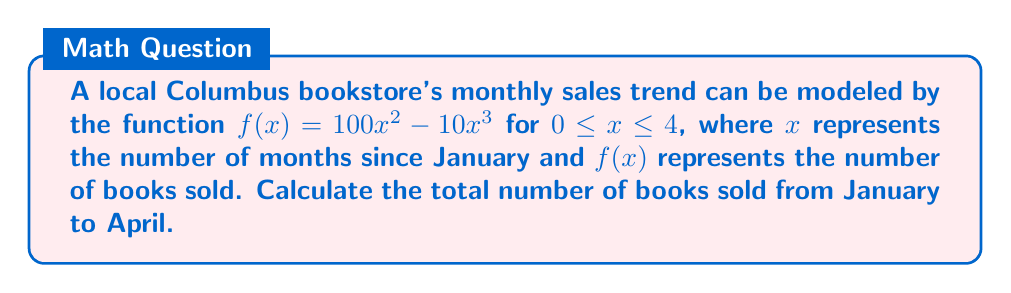Give your solution to this math problem. To find the total number of books sold from January to April, we need to calculate the area under the curve $f(x) = 100x^2 - 10x^3$ from $x = 0$ to $x = 4$. This can be done using a definite integral.

Step 1: Set up the definite integral
$$\int_0^4 (100x^2 - 10x^3) dx$$

Step 2: Integrate the function
$$\left[\frac{100x^3}{3} - \frac{10x^4}{4}\right]_0^4$$

Step 3: Evaluate the integral at the upper and lower bounds
$$\left(\frac{100(4^3)}{3} - \frac{10(4^4)}{4}\right) - \left(\frac{100(0^3)}{3} - \frac{10(0^4)}{4}\right)$$

Step 4: Simplify
$$\left(\frac{6400}{3} - 640\right) - (0 - 0)$$
$$\approx 2133.33 - 640 = 1493.33$$

Step 5: Round to the nearest whole number (since we can't sell partial books)
The total number of books sold is approximately 1493.
Answer: 1493 books 